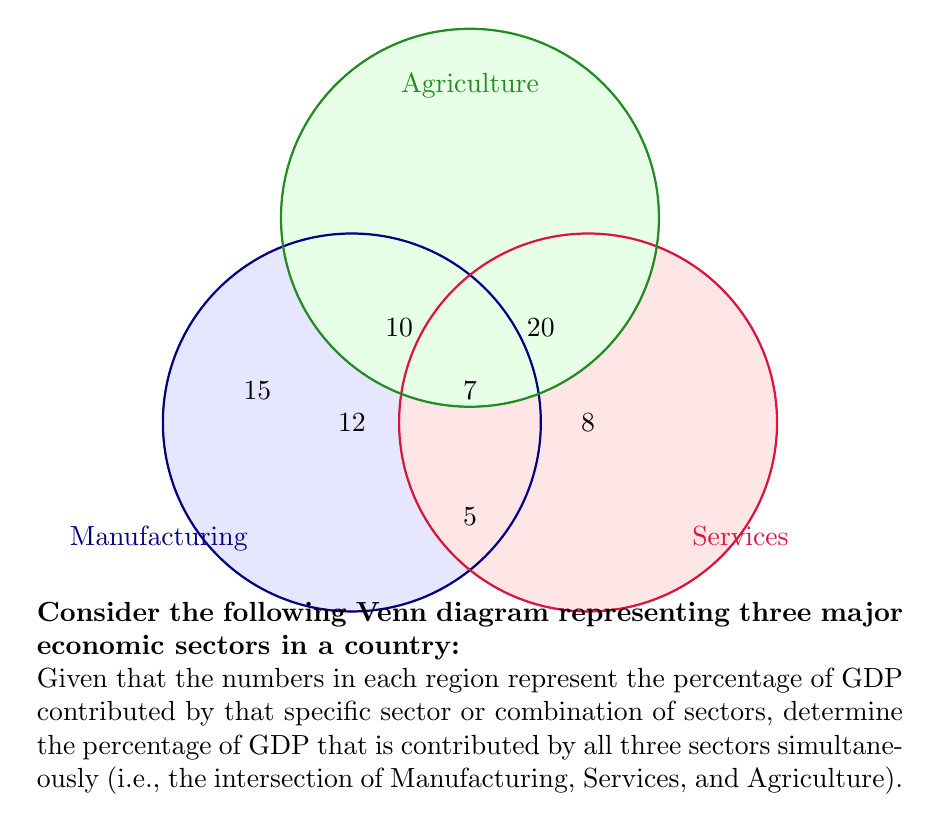Solve this math problem. To solve this problem, we need to identify the region where all three sets intersect and find the value in that region. Let's approach this step-by-step:

1) The Venn diagram shows three overlapping circles representing Manufacturing, Services, and Agriculture sectors.

2) The central region where all three circles overlap represents the intersection of all three sectors.

3) In set theory notation, we are looking for:
   $$ \text{Manufacturing} \cap \text{Services} \cap \text{Agriculture} $$

4) The value in this central region is 7, which represents the percentage of GDP contributed by activities that fall under all three sectors simultaneously.

5) This could represent, for example, activities like food processing, which involves elements of manufacturing, services, and agriculture.

6) To verify, we can sum all the percentages:
   $$ 15 + 10 + 20 + 5 + 12 + 8 + 7 = 77\% $$
   
   The total is less than 100% because there might be other minor sectors not represented in this diagram.

Therefore, the percentage of GDP contributed by all three sectors simultaneously is 7%.
Answer: 7% 